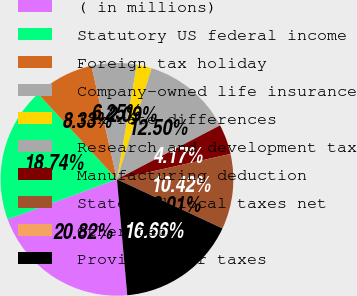Convert chart to OTSL. <chart><loc_0><loc_0><loc_500><loc_500><pie_chart><fcel>( in millions)<fcel>Statutory US federal income<fcel>Foreign tax holiday<fcel>Company-owned life insurance<fcel>Tax rate differences<fcel>Research and development tax<fcel>Manufacturing deduction<fcel>State and local taxes net<fcel>Other net<fcel>Provision for taxes<nl><fcel>20.82%<fcel>18.74%<fcel>8.33%<fcel>6.25%<fcel>2.09%<fcel>12.5%<fcel>4.17%<fcel>10.42%<fcel>0.01%<fcel>16.66%<nl></chart> 